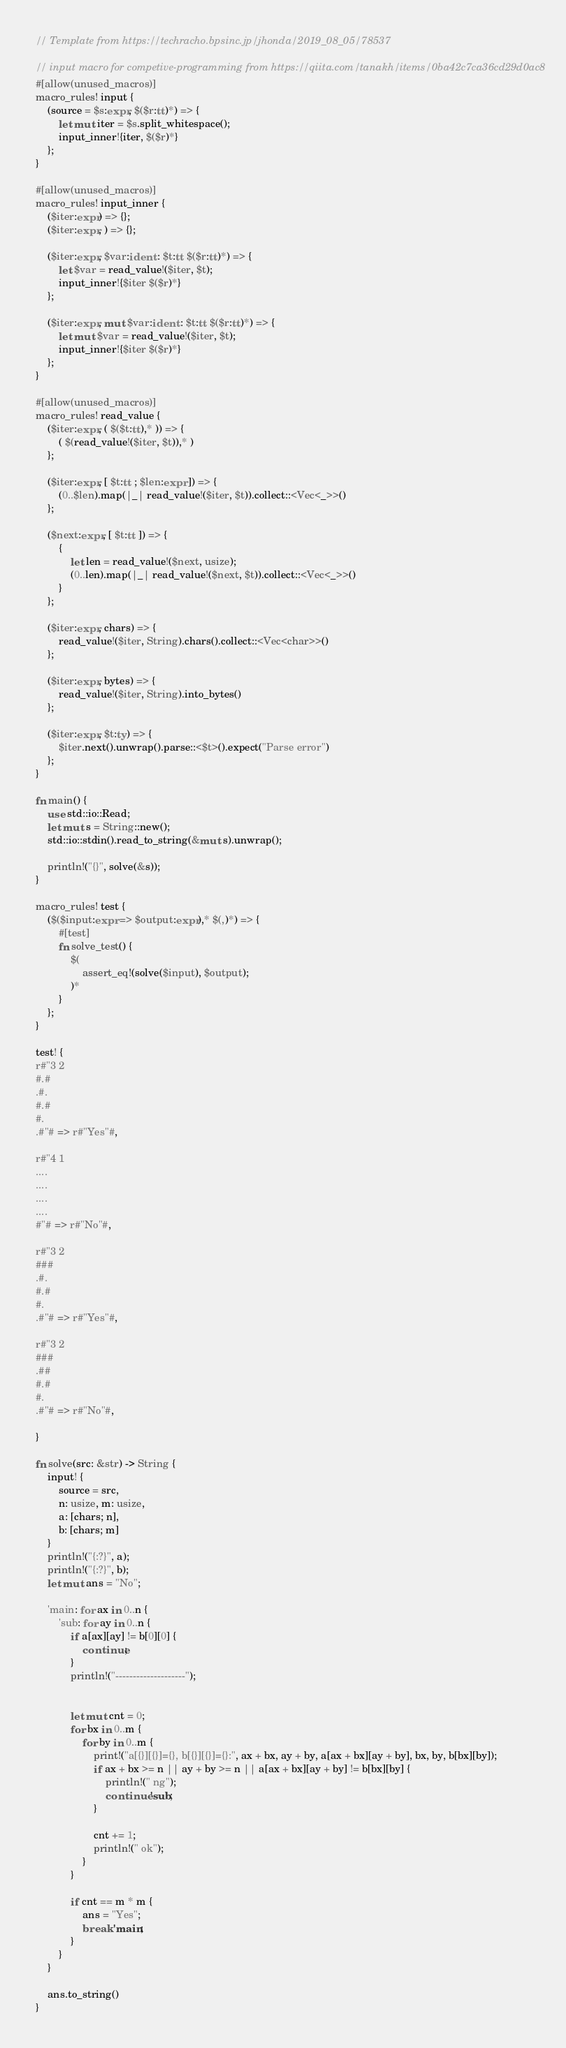Convert code to text. <code><loc_0><loc_0><loc_500><loc_500><_Rust_>// Template from https://techracho.bpsinc.jp/jhonda/2019_08_05/78537

// input macro for competive-programming from https://qiita.com/tanakh/items/0ba42c7ca36cd29d0ac8
#[allow(unused_macros)]
macro_rules! input {
    (source = $s:expr, $($r:tt)*) => {
        let mut iter = $s.split_whitespace();
        input_inner!{iter, $($r)*}
    };
}

#[allow(unused_macros)]
macro_rules! input_inner {
    ($iter:expr) => {};
    ($iter:expr, ) => {};

    ($iter:expr, $var:ident : $t:tt $($r:tt)*) => {
        let $var = read_value!($iter, $t);
        input_inner!{$iter $($r)*}
    };

    ($iter:expr, mut $var:ident : $t:tt $($r:tt)*) => {
        let mut $var = read_value!($iter, $t);
        input_inner!{$iter $($r)*}
    };
}

#[allow(unused_macros)]
macro_rules! read_value {
    ($iter:expr, ( $($t:tt),* )) => {
        ( $(read_value!($iter, $t)),* )
    };

    ($iter:expr, [ $t:tt ; $len:expr ]) => {
        (0..$len).map(|_| read_value!($iter, $t)).collect::<Vec<_>>()
    };

    ($next:expr, [ $t:tt ]) => {
        {
            let len = read_value!($next, usize);
            (0..len).map(|_| read_value!($next, $t)).collect::<Vec<_>>()
        }
    };

    ($iter:expr, chars) => {
        read_value!($iter, String).chars().collect::<Vec<char>>()
    };

    ($iter:expr, bytes) => {
        read_value!($iter, String).into_bytes()
    };

    ($iter:expr, $t:ty) => {
        $iter.next().unwrap().parse::<$t>().expect("Parse error")
    };
}

fn main() {
    use std::io::Read;
    let mut s = String::new();
    std::io::stdin().read_to_string(&mut s).unwrap();

    println!("{}", solve(&s));
}

macro_rules! test {
    ($($input:expr => $output:expr),* $(,)*) => {
        #[test]
        fn solve_test() {
            $(
                assert_eq!(solve($input), $output);
            )*
        }
    };
}

test! {
r#"3 2
#.#
.#.
#.#
#.
.#"# => r#"Yes"#,

r#"4 1
....
....
....
....
#"# => r#"No"#,

r#"3 2
###
.#.
#.#
#.
.#"# => r#"Yes"#,

r#"3 2
###
.##
#.#
#.
.#"# => r#"No"#,

}

fn solve(src: &str) -> String {
    input! {
        source = src,
        n: usize, m: usize,
        a: [chars; n],
        b: [chars; m]
    }
    println!("{:?}", a);
    println!("{:?}", b);
    let mut ans = "No";

    'main: for ax in 0..n {
        'sub: for ay in 0..n {
            if a[ax][ay] != b[0][0] {
                continue;
            }
            println!("--------------------");


            let mut cnt = 0;
            for bx in 0..m {
                for by in 0..m {
                    print!("a[{}][{}]={}, b[{}][{}]={}:", ax + bx, ay + by, a[ax + bx][ay + by], bx, by, b[bx][by]);
                    if ax + bx >= n || ay + by >= n || a[ax + bx][ay + by] != b[bx][by] {
                        println!(" ng");
                        continue 'sub;
                    }

                    cnt += 1;
                    println!(" ok");
                }
            }

            if cnt == m * m {
                ans = "Yes";
                break 'main;
            }
        }
    }

    ans.to_string()
}</code> 